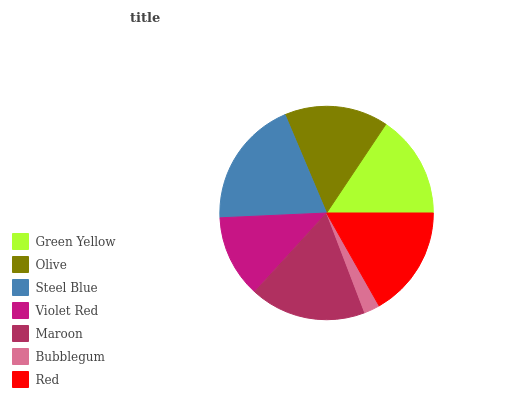Is Bubblegum the minimum?
Answer yes or no. Yes. Is Steel Blue the maximum?
Answer yes or no. Yes. Is Olive the minimum?
Answer yes or no. No. Is Olive the maximum?
Answer yes or no. No. Is Olive greater than Green Yellow?
Answer yes or no. Yes. Is Green Yellow less than Olive?
Answer yes or no. Yes. Is Green Yellow greater than Olive?
Answer yes or no. No. Is Olive less than Green Yellow?
Answer yes or no. No. Is Olive the high median?
Answer yes or no. Yes. Is Olive the low median?
Answer yes or no. Yes. Is Maroon the high median?
Answer yes or no. No. Is Steel Blue the low median?
Answer yes or no. No. 